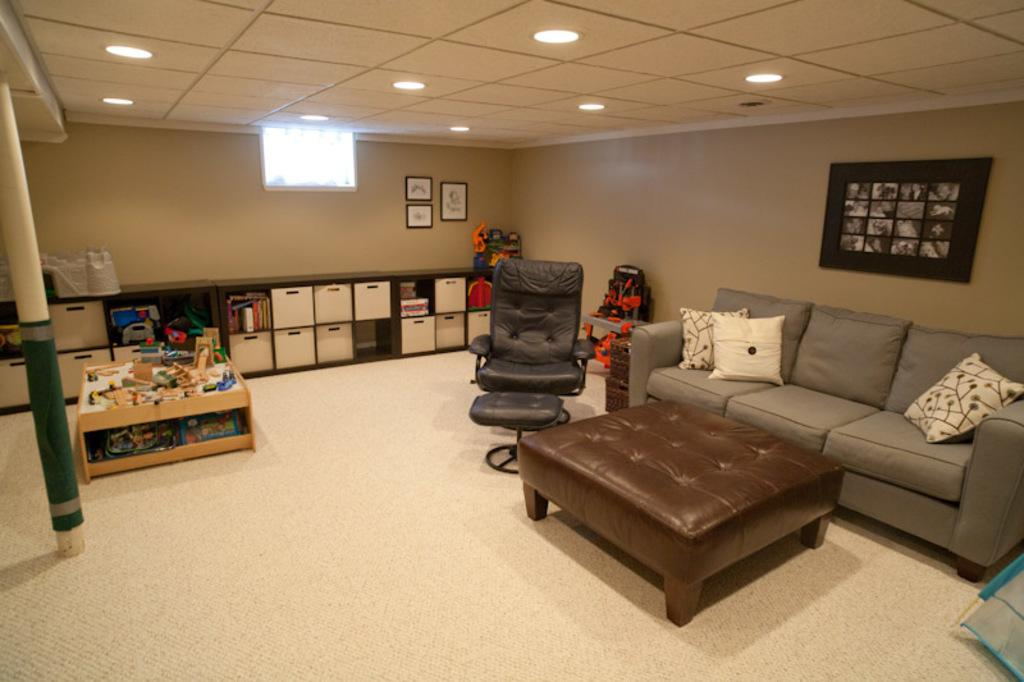What type of furniture is present in the image? There is a sofa, a chair, and a table in the image. What is the primary function of the table in the image? The table is likely used for placing objects or for eating or working. What other objects can be seen on the floor in the image? There are other objects on the floor in the image, but their specific nature is not mentioned in the provided facts. Is the person using a quill to write on the sofa in the image? There is no person or quill present in the image, so this scenario cannot be observed. 